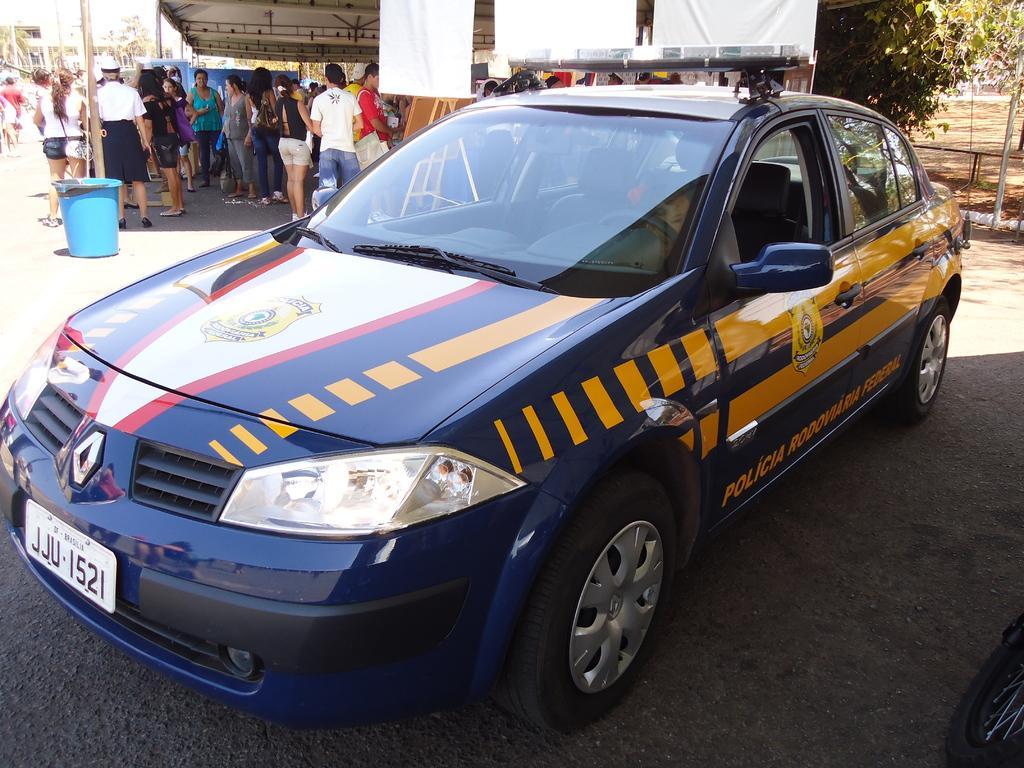How would you summarize this image in a sentence or two? In this image there is a police vehicle parked on the road. In the background there are people standing under the roof. There is also a pole, dustbin and posters. Image also consists of trees. 